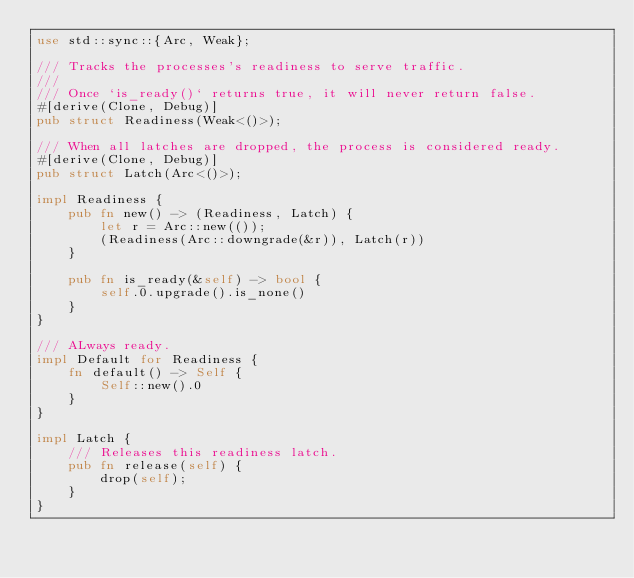<code> <loc_0><loc_0><loc_500><loc_500><_Rust_>use std::sync::{Arc, Weak};

/// Tracks the processes's readiness to serve traffic.
///
/// Once `is_ready()` returns true, it will never return false.
#[derive(Clone, Debug)]
pub struct Readiness(Weak<()>);

/// When all latches are dropped, the process is considered ready.
#[derive(Clone, Debug)]
pub struct Latch(Arc<()>);

impl Readiness {
    pub fn new() -> (Readiness, Latch) {
        let r = Arc::new(());
        (Readiness(Arc::downgrade(&r)), Latch(r))
    }

    pub fn is_ready(&self) -> bool {
        self.0.upgrade().is_none()
    }
}

/// ALways ready.
impl Default for Readiness {
    fn default() -> Self {
        Self::new().0
    }
}

impl Latch {
    /// Releases this readiness latch.
    pub fn release(self) {
        drop(self);
    }
}
</code> 